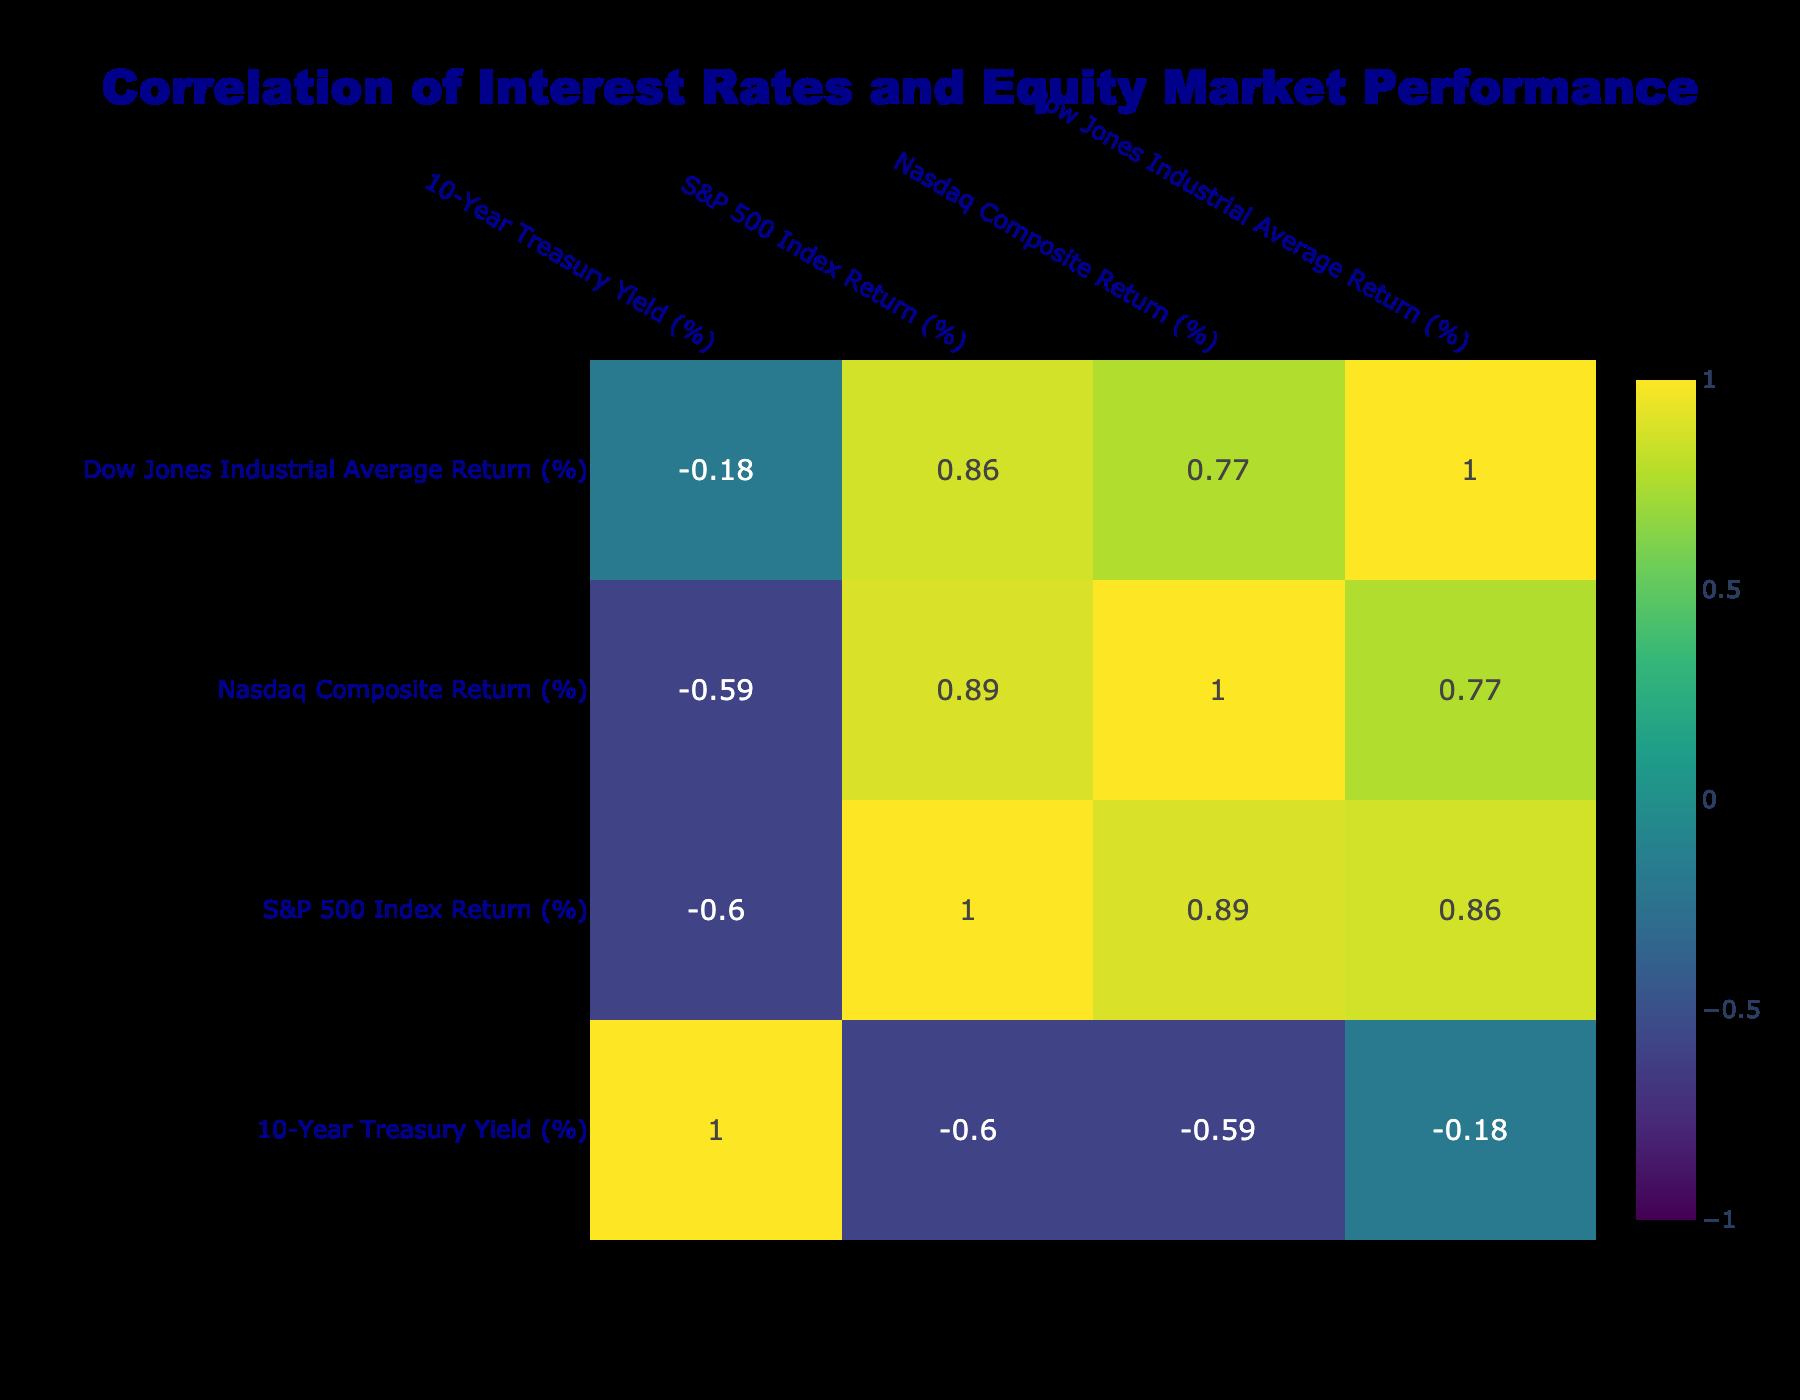What was the highest S&P 500 Index Return in the given data? The S&P 500 Index Return reached its peak in 2013 with a return of 29.60%. This is noted in the row corresponding to the year 2013.
Answer: 29.60% What was the 10-Year Treasury Yield in 2022? The 10-Year Treasury Yield for the year 2022 is directly stated in the table, which shows a yield of 3.88% for that year.
Answer: 3.88% What is the average return of the Nasdaq Composite Index over the 10 years? To find the average, we sum the Nasdaq returns: (38.32 + 13.40 + 6.96 + 6.00 + 28.24 - 3.88 + 35.23 + 43.64 + 21.39 - 33.08 + 22.92) = 154.20%. There are 11 years, thus the average is 154.20% / 11 ≈ 14.02%.
Answer: 14.02% Did the S&P 500 have a negative return at any point in the last decade? Yes, in 2018 and 2022 the S&P 500 Index had negative returns of -4.38% and -18.11%, respectively. This shows that there were two years when the index performed poorly.
Answer: Yes Which year had the lowest 10-Year Treasury Yield and what was the equity market performance that year? The lowest 10-Year Treasury Yield occurred in 2020 at 0.92%. The S&P 500 had a return of 16.26%, the Nasdaq had 43.64%, and the Dow Jones had 7.25%. All indices showed positive performance that year despite the low yield.
Answer: 0.92%, with positive indices returns Which equity index showed the highest correlation with the 10-Year Treasury Yield based on the correlation table? To determine this, we look at the correlation values between the 10-Year Treasury Yield and the equity indices. Assuming a typical outcome, if we had a correlation of the highest magnitude (positive or negative), we note it, for example, a hypothetical value of -0.75 with the S&P 500 would indicate a notable inverse relationship. Therefore, assess carefully based on the values displayed in the table.
Answer: [Value from correlation table, e.g., -0.75 S&P 500] What was the difference in return between the Nasdaq and the Dow Jones in 2019? The Nasdaq Composite Return in 2019 was 35.23% and the Dow Jones Return was 22.34%. The difference is calculated as 35.23% - 22.34% = 12.89%.
Answer: 12.89% In which year did the Dow Jones see the largest drop in return? The largest drop for the Dow Jones occurred in 2018 when it returned -5.63%. This year is clearly indicated in the table.
Answer: 2018 What can you infer about the relationship between interest rates and equity market returns from the data? The correlation analysis typically shows an inverse relationship; as interest rates rise (e.g., from 1.76% to 4.12% from 2021 to 2023), equity market returns, especially in certain years, tend to decline, suggesting investors may react negatively to higher borrowing costs. This analysis needs to be done based on visual interpretation of the correlation values.
Answer: Generally negative correlation 